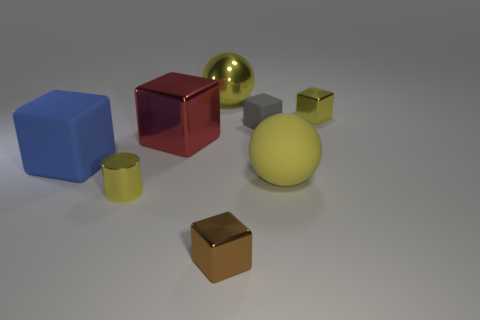Do the tiny cube that is left of the gray matte object and the tiny gray block have the same material?
Offer a terse response. No. What number of other objects are the same material as the gray cube?
Give a very brief answer. 2. There is a red object that is the same size as the blue rubber cube; what is its material?
Offer a terse response. Metal. Does the thing that is right of the matte sphere have the same shape as the small yellow metal thing to the left of the tiny brown block?
Ensure brevity in your answer.  No. What shape is the red object that is the same size as the blue block?
Your answer should be very brief. Cube. Do the sphere on the right side of the tiny brown metallic thing and the small block in front of the small gray cube have the same material?
Provide a succinct answer. No. There is a ball that is left of the large yellow matte ball; is there a large blue block behind it?
Your response must be concise. No. What color is the big object that is made of the same material as the blue block?
Ensure brevity in your answer.  Yellow. Is the number of small yellow metal blocks greater than the number of large cyan cylinders?
Provide a short and direct response. Yes. How many things are either metal cubes that are in front of the yellow cylinder or metal balls?
Keep it short and to the point. 2. 